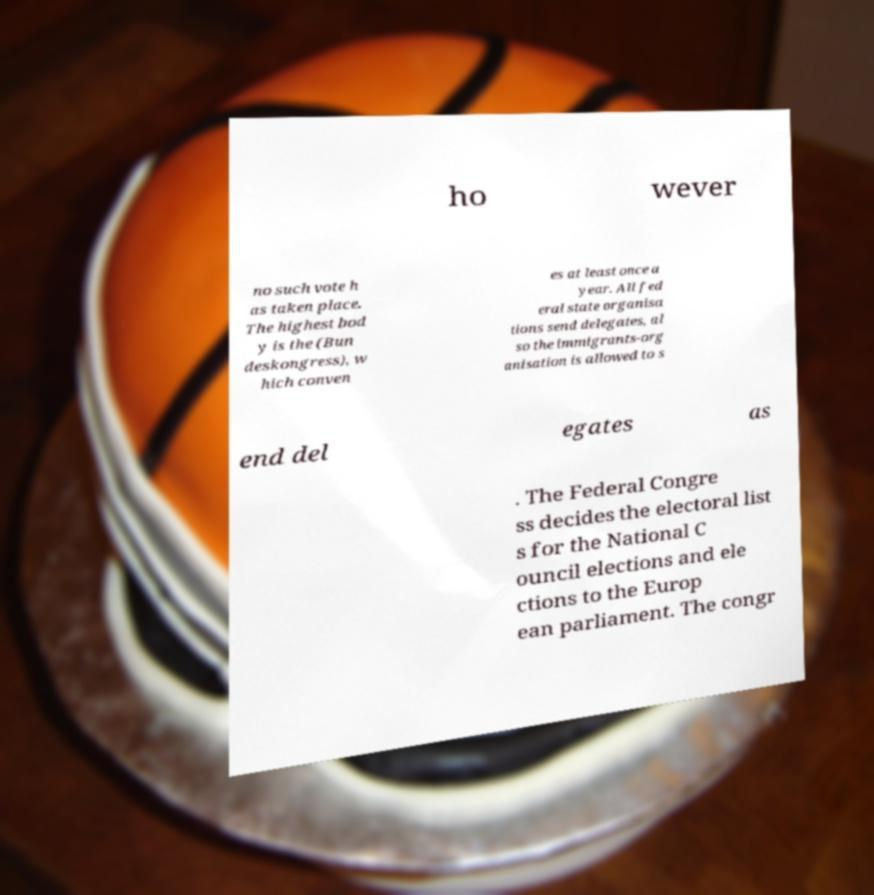Could you extract and type out the text from this image? ho wever no such vote h as taken place. The highest bod y is the (Bun deskongress), w hich conven es at least once a year. All fed eral state organisa tions send delegates, al so the immigrants-org anisation is allowed to s end del egates as . The Federal Congre ss decides the electoral list s for the National C ouncil elections and ele ctions to the Europ ean parliament. The congr 